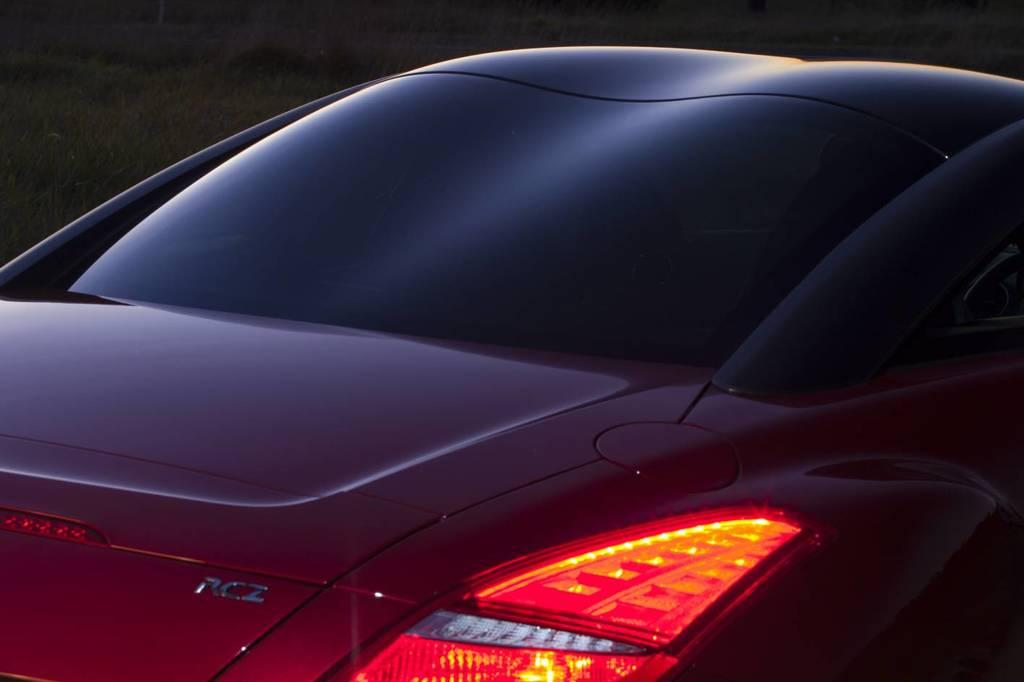What is the main subject of the image? The main subject of the image is a car. What features can be seen on the car? The car has lights and a logo. What other object is visible in the image? There is a glass in the image. What type of vegetation is beside the car in the image? There is grass beside the car in the image. How many cacti can be seen in the image? There are no cacti present in the image. Is there any indication of a battle taking place in the image? There is no indication of a battle or any conflict in the image. 